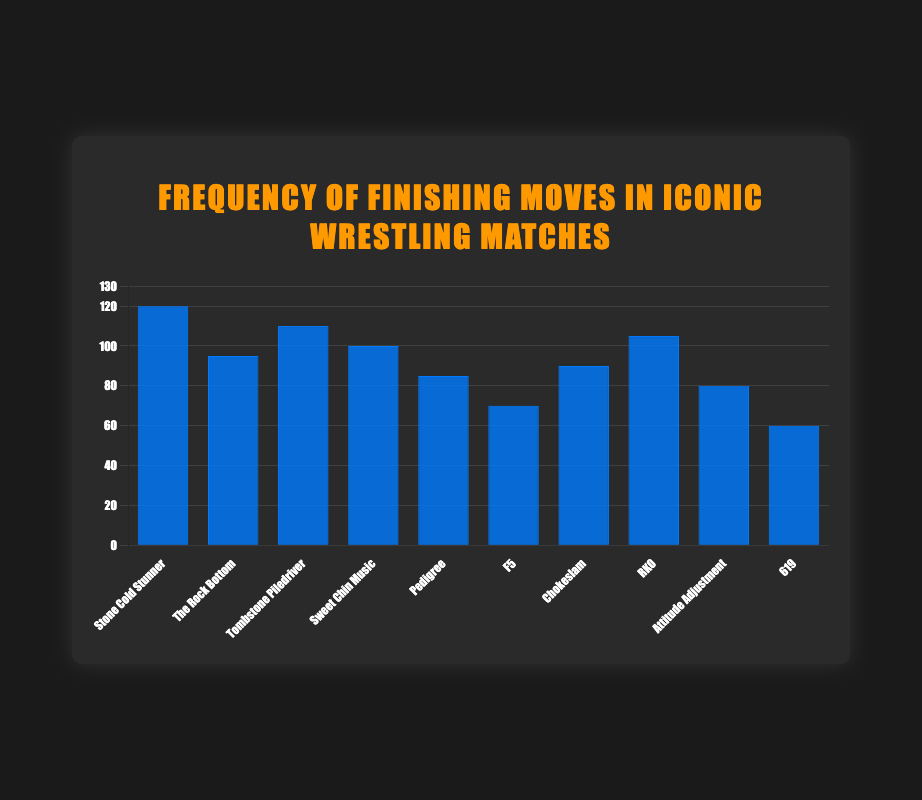What's the most frequently used finishing move in iconic wrestling matches? The chart shows that the "Stone Cold Stunner" has the highest count among all finishing moves.
Answer: Stone Cold Stunner Which finishing move is used more frequently: "The Rock Bottom" or "Attitude Adjustment"? The chart shows "The Rock Bottom" with a count of 95 and "Attitude Adjustment" with a count of 80. 95 is greater than 80.
Answer: The Rock Bottom What is the difference in frequency between the most and least frequently used finishing moves? The most frequent move is "Stone Cold Stunner" with 120 instances, and the least frequent is "619" with 60 instances. The difference is 120 - 60.
Answer: 60 How many finishing moves have a frequency of 100 or more? The finishing moves with a frequency of 100 or more are "Stone Cold Stunner", "The Rock Bottom", "Tombstone Piledriver", "Sweet Chin Music", and "RKO". There are 5 such moves.
Answer: 5 Which finishing move has slightly fewer uses than "Sweet Chin Music"? "Sweet Chin Music" has 100 instances, and the move with slightly fewer uses is "RKO" with 105 instances.
Answer: RKO What is the average frequency of the five least used finishing moves? The frequencies of the five least used finishing moves are "619" (60), "F5" (70), "Attitude Adjustment" (80), "Pedigree" (85), and "Chokeslam" (90). The sum is 60 + 70 + 80 + 85 + 90 = 385. The average is 385 / 5.
Answer: 77 Compare the total frequency of "Tombstone Piledriver" and "Pedigree" to that of "Stone Cold Stunner". Which is higher? "Tombstone Piledriver" has 110 instances, "Pedigree" has 85. Their total is 110 + 85 = 195. "Stone Cold Stunner" has 120 instances. 195 is greater than 120.
Answer: Tombstone Piledriver and Pedigree How does the visual height of the bar for "RKO" compare to the bar for "Sweet Chin Music"? The visual height of the bar for "RKO" is greater than that for "Sweet Chin Music" because "RKO" has a count of 105 while "Sweet Chin Music" has 100.
Answer: Higher What's the sum of frequencies for moves "F5", "Chokeslam", and "619"? The counts are "F5" (70), "Chokeslam" (90), and "619" (60). The sum is 70 + 90 + 60 = 220.
Answer: 220 